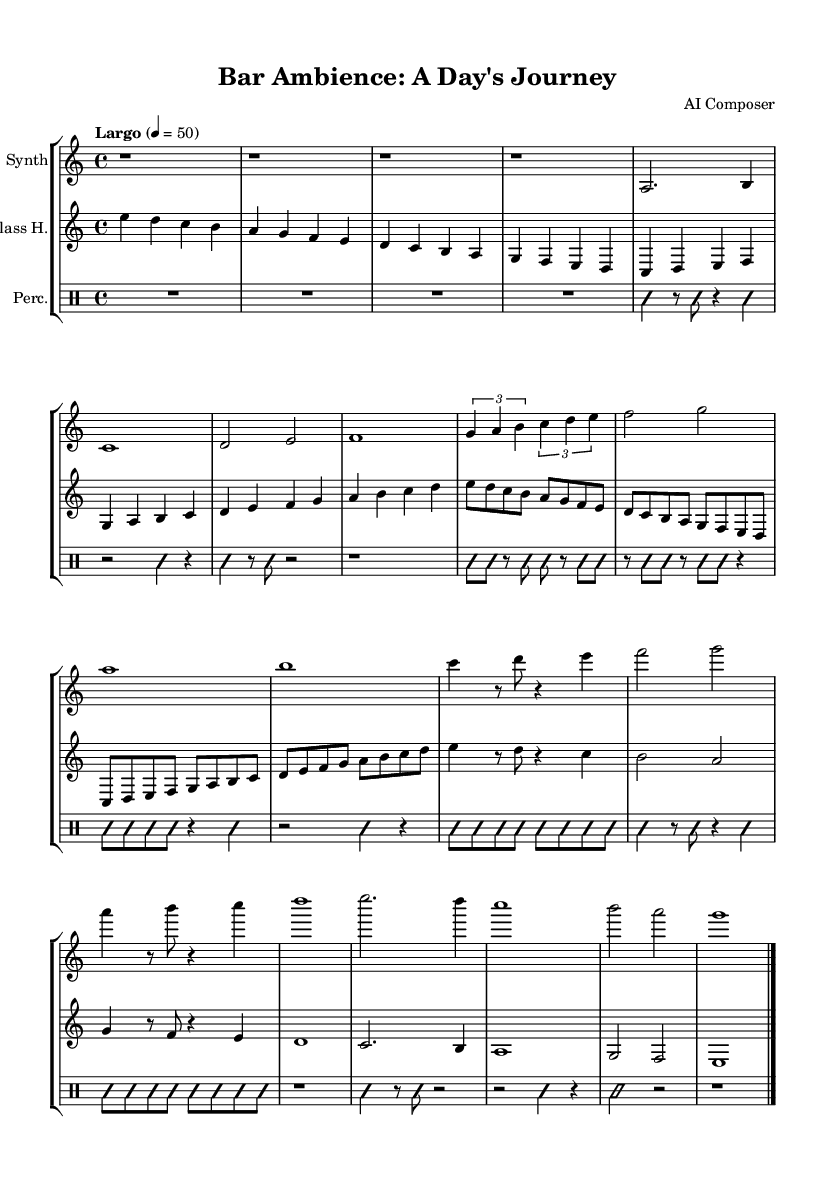What is the key signature of this music? The key signature is C major, which is indicated by the absence of sharps or flats in the score. As there are no accidental notes present, we can confirm it matches the C major scale.
Answer: C major What is the tempo marking indicated in the music? The tempo marking is "Largo," which is stated at the beginning of the score. The numerical value indicates a tempo of 50 beats per minute.
Answer: Largo What is the time signature of this music? The time signature is 4/4, shown right after the tempo marking in the score. This means there are four beats in a measure, and the quarter note gets one beat.
Answer: 4/4 How many sections are present in the piece? The score consists of four main sections: Introduction, Morning Calm, Midday Rush, Evening Buzz, and Last Call. Each section captures a different aspect of the bar’s ambience throughout the day.
Answer: Five Which instrument plays the introduction section? The introduction section is played by the synthesizer, as indicated at the beginning of its respective staff. The other instruments join in later sections of the score.
Answer: Synthesizer What rhythmic elements are used in the midday rush section? The midday rush section prominently features eighth notes organized in tuples form, creating a more frenetic pace. This contrasts with the more relaxed rhythms in the earlier sections.
Answer: Eighth notes and tuples What does the indication "improvisationOn" imply in the percussion part? The indication “improvisationOn” denotes that the percussionist is allowed to improvise, meaning they can create rhythmic patterns spontaneously rather than strictly following notated rhythms. This section likely adds to the chaotic atmosphere of the bar.
Answer: Improvisation 